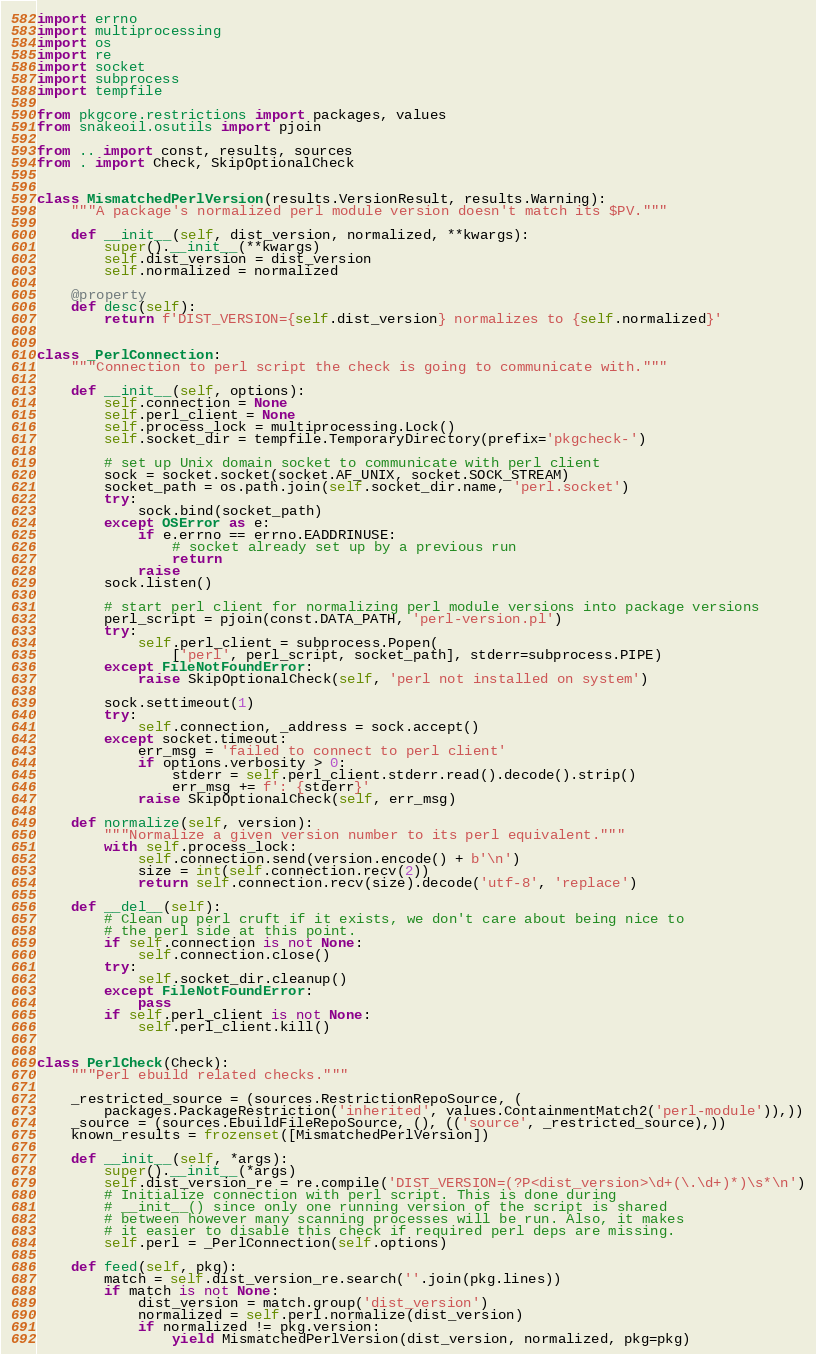<code> <loc_0><loc_0><loc_500><loc_500><_Python_>import errno
import multiprocessing
import os
import re
import socket
import subprocess
import tempfile

from pkgcore.restrictions import packages, values
from snakeoil.osutils import pjoin

from .. import const, results, sources
from . import Check, SkipOptionalCheck


class MismatchedPerlVersion(results.VersionResult, results.Warning):
    """A package's normalized perl module version doesn't match its $PV."""

    def __init__(self, dist_version, normalized, **kwargs):
        super().__init__(**kwargs)
        self.dist_version = dist_version
        self.normalized = normalized

    @property
    def desc(self):
        return f'DIST_VERSION={self.dist_version} normalizes to {self.normalized}'


class _PerlConnection:
    """Connection to perl script the check is going to communicate with."""

    def __init__(self, options):
        self.connection = None
        self.perl_client = None
        self.process_lock = multiprocessing.Lock()
        self.socket_dir = tempfile.TemporaryDirectory(prefix='pkgcheck-')

        # set up Unix domain socket to communicate with perl client
        sock = socket.socket(socket.AF_UNIX, socket.SOCK_STREAM)
        socket_path = os.path.join(self.socket_dir.name, 'perl.socket')
        try:
            sock.bind(socket_path)
        except OSError as e:
            if e.errno == errno.EADDRINUSE:
                # socket already set up by a previous run
                return
            raise
        sock.listen()

        # start perl client for normalizing perl module versions into package versions
        perl_script = pjoin(const.DATA_PATH, 'perl-version.pl')
        try:
            self.perl_client = subprocess.Popen(
                ['perl', perl_script, socket_path], stderr=subprocess.PIPE)
        except FileNotFoundError:
            raise SkipOptionalCheck(self, 'perl not installed on system')

        sock.settimeout(1)
        try:
            self.connection, _address = sock.accept()
        except socket.timeout:
            err_msg = 'failed to connect to perl client'
            if options.verbosity > 0:
                stderr = self.perl_client.stderr.read().decode().strip()
                err_msg += f': {stderr}'
            raise SkipOptionalCheck(self, err_msg)

    def normalize(self, version):
        """Normalize a given version number to its perl equivalent."""
        with self.process_lock:
            self.connection.send(version.encode() + b'\n')
            size = int(self.connection.recv(2))
            return self.connection.recv(size).decode('utf-8', 'replace')

    def __del__(self):
        # Clean up perl cruft if it exists, we don't care about being nice to
        # the perl side at this point.
        if self.connection is not None:
            self.connection.close()
        try:
            self.socket_dir.cleanup()
        except FileNotFoundError:
            pass
        if self.perl_client is not None:
            self.perl_client.kill()


class PerlCheck(Check):
    """Perl ebuild related checks."""

    _restricted_source = (sources.RestrictionRepoSource, (
        packages.PackageRestriction('inherited', values.ContainmentMatch2('perl-module')),))
    _source = (sources.EbuildFileRepoSource, (), (('source', _restricted_source),))
    known_results = frozenset([MismatchedPerlVersion])

    def __init__(self, *args):
        super().__init__(*args)
        self.dist_version_re = re.compile('DIST_VERSION=(?P<dist_version>\d+(\.\d+)*)\s*\n')
        # Initialize connection with perl script. This is done during
        # __init__() since only one running version of the script is shared
        # between however many scanning processes will be run. Also, it makes
        # it easier to disable this check if required perl deps are missing.
        self.perl = _PerlConnection(self.options)

    def feed(self, pkg):
        match = self.dist_version_re.search(''.join(pkg.lines))
        if match is not None:
            dist_version = match.group('dist_version')
            normalized = self.perl.normalize(dist_version)
            if normalized != pkg.version:
                yield MismatchedPerlVersion(dist_version, normalized, pkg=pkg)
</code> 